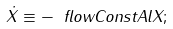<formula> <loc_0><loc_0><loc_500><loc_500>\dot { X } \equiv - \ f l o w C o n s t A l X ;</formula> 